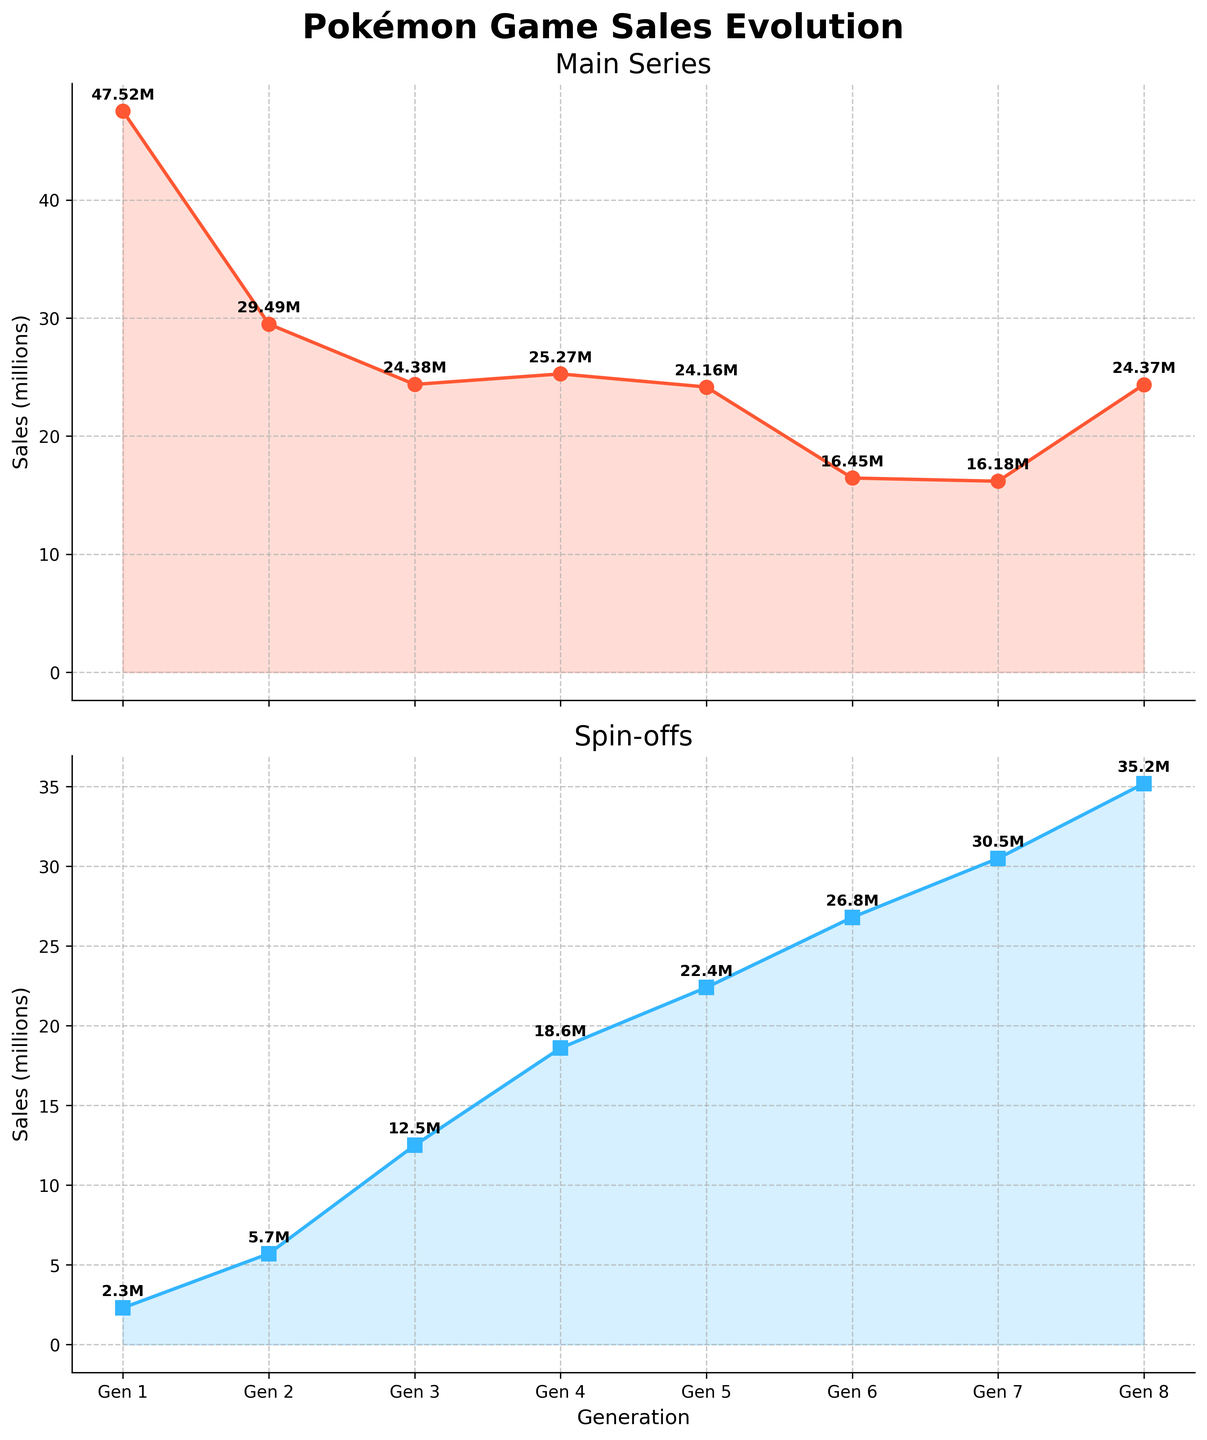What is the title of the figure? The title is located at the top of the figure, displayed prominently in a bold font.
Answer: Pokémon Game Sales Evolution Which generation has the highest sales for the main series? By analyzing the line graph for the main series, the highest point corresponds to Generation 1 with 47.52 million.
Answer: Generation 1 How have spin-off sales evolved compared to main series sales over generations? By comparing the trends of the two lines, spin-off sales show a consistent increase, unlike the main series, which showed a decreasing trend after Generation 1 with slight variations.
Answer: Spin-off sales increased, main series sales showed variations with a general decline after Gen 1 What is the difference in sales between the main series and spin-offs for Generation 4? Look for the data points on both line charts for Generation 4. Main series sales are 25.27 million, and spin-offs are 18.6 million. The difference is 25.27 - 18.6 = 6.67 million.
Answer: 6.67 million Which generation had the lowest sales for the main series? By observing the lowest point in the main series plot, Generation 7 has the lowest sales with 16.18 million.
Answer: Generation 7 Is there any generation where spin-off sales surpassed main series sales? By comparing the y-values of both lines for each generation, from Generation 5 onwards, spin-offs consistently had higher sales than the main series.
Answer: Yes, from Generation 5 onward What is the approximate trend in sales for the main series from Generation 1 to Generation 8? The main series shows an initial decline until Generation 6, slight rise in Generation 8 compared to Generation 7.
Answer: Initially declining, slight rise in Gen 8 compared to Gen 7 Which generation saw the largest increase in spin-off sales compared to the previous generation? Compare consecutive spin-off sales values: Largest increase is from Generation 2 to Generation 3 (5.7 to 12.5, an increase of 6.8 million), then from Gen 3 to Gen 4 (12.5 to 18.6, increase of 6.1 million).
Answer: Generation 3 What is the total sales for both main series and spin-offs for Generation 6? Add the sales of main series and spin-offs for Generation 6: 16.45 + 26.8 = 43.25 million.
Answer: 43.25 million 